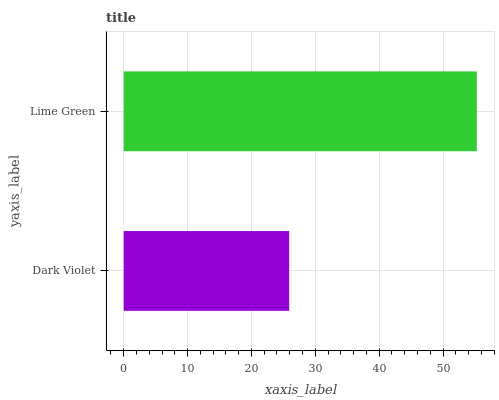Is Dark Violet the minimum?
Answer yes or no. Yes. Is Lime Green the maximum?
Answer yes or no. Yes. Is Lime Green the minimum?
Answer yes or no. No. Is Lime Green greater than Dark Violet?
Answer yes or no. Yes. Is Dark Violet less than Lime Green?
Answer yes or no. Yes. Is Dark Violet greater than Lime Green?
Answer yes or no. No. Is Lime Green less than Dark Violet?
Answer yes or no. No. Is Lime Green the high median?
Answer yes or no. Yes. Is Dark Violet the low median?
Answer yes or no. Yes. Is Dark Violet the high median?
Answer yes or no. No. Is Lime Green the low median?
Answer yes or no. No. 